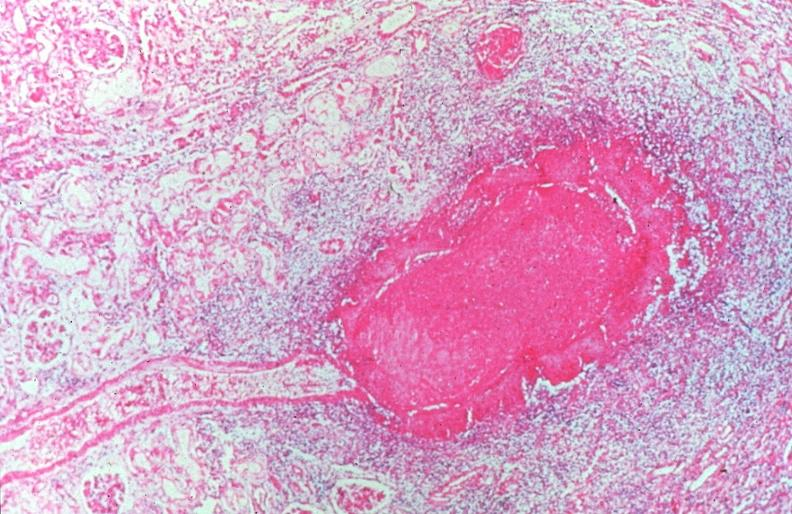what is present?
Answer the question using a single word or phrase. Cardiovascular 